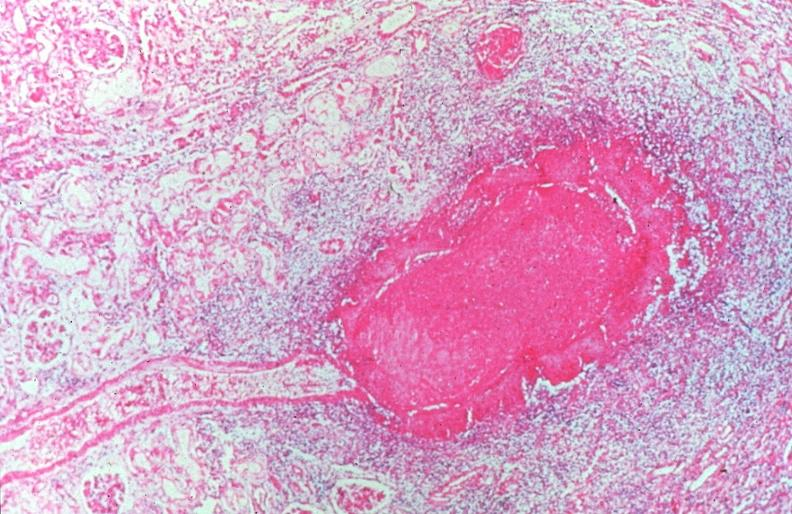what is present?
Answer the question using a single word or phrase. Cardiovascular 